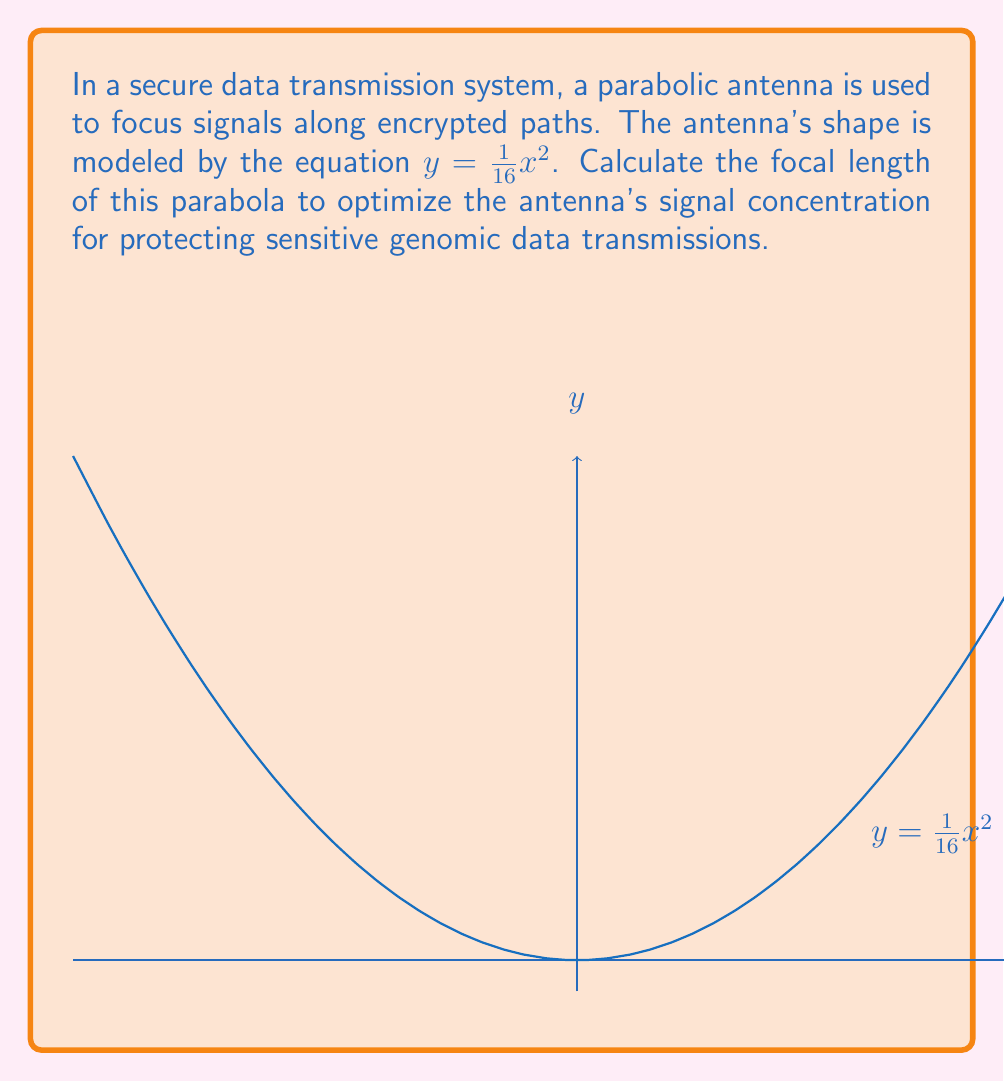Solve this math problem. To find the focal length of the parabola, we'll follow these steps:

1) The general form of a parabola with vertex at the origin is:

   $y = \frac{1}{4p}x^2$

   where $p$ is the focal length.

2) Our parabola equation is:

   $y = \frac{1}{16}x^2$

3) Comparing our equation to the general form, we can see that:

   $\frac{1}{4p} = \frac{1}{16}$

4) Solving for $p$:

   $p = \frac{1}{4} \cdot 16 = 4$

5) Therefore, the focal length of the parabola is 4 units.

In the context of cybersecurity and protecting genomic data, this focal length determines the optimal point where the antenna concentrates the signal. A precise focal length ensures that encrypted data transmissions are focused accurately, minimizing the risk of interception or data loss.
Answer: $4$ units 